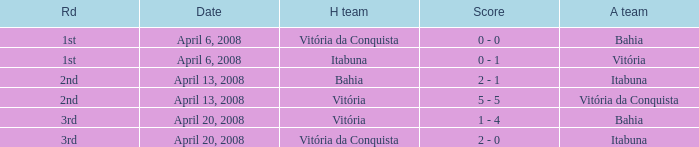What is the name of the home team with a round of 2nd and Vitória da Conquista as the way team? Vitória. 